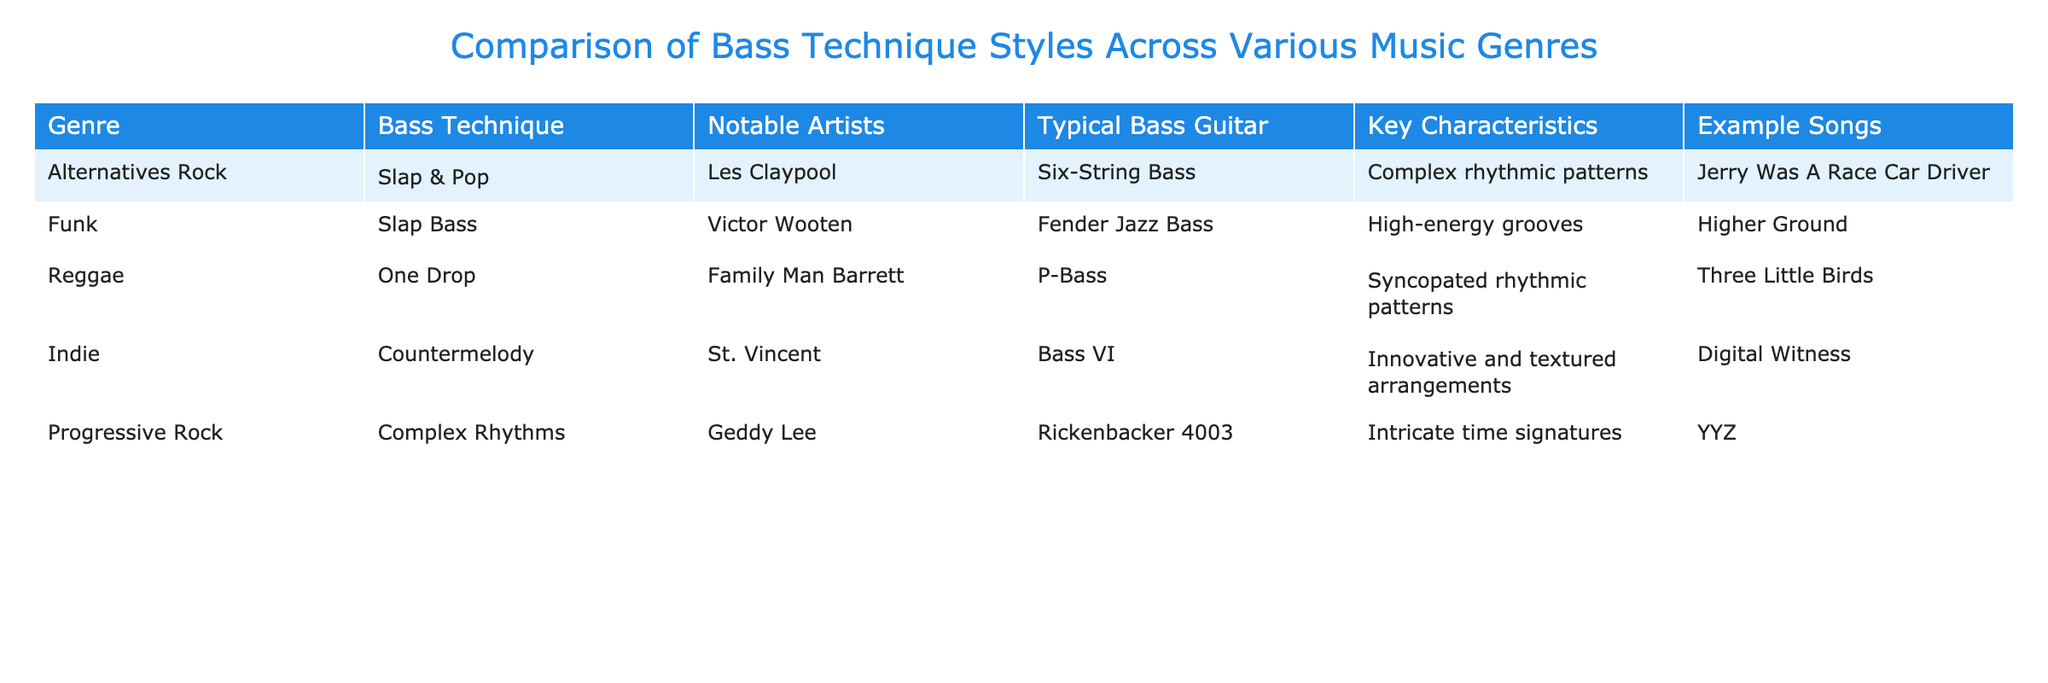What bass technique is associated with Alternatives Rock? The table indicates that the bass technique for Alternatives Rock is "Slap & Pop."
Answer: Slap & Pop Who is the notable artist linked to the slap bass technique? According to the table, Victor Wooten is the notable artist associated with the slap bass technique.
Answer: Victor Wooten What is the typical bass guitar used in Reggae? The table shows that the typical bass guitar for Reggae is "P-Bass."
Answer: P-Bass Which genre features intricate time signatures as a key characteristic? The table highlights that Progressive Rock features intricate time signatures as a key characteristic.
Answer: Progressive Rock Are there any genres that use the same bass guitar? Yes, both Funk and Reggae use the Fender Jazz Bass as their typical bass guitar.
Answer: Yes What is the notable artist for Indie music known for innovative arrangements? The table specifies that St. Vincent is the notable artist for Indie music, recognized for innovative and textured arrangements.
Answer: St. Vincent How many genres use a slap bass technique? From the table, Funk and Alternatives Rock both utilize a slap bass technique, making it two genres.
Answer: 2 Which genre has "Three Little Birds" as an example song? The table indicates that "Three Little Birds" is an example song for the Reggae genre.
Answer: Reggae List the two genres that feature complex rhythmic patterns. The table shows that Alternatives Rock and Funk both feature complex rhythmic patterns in their key characteristics.
Answer: Alternatives Rock and Funk What is the relationship between the bass technique and its notable artist in Alternates Rock? The table illustrates that in Alternatives Rock, "Slap & Pop" is the bass technique, and "Les Claypool" is the associated notable artist. Les Claypool is known for using this technique.
Answer: Les Claypool How many notable artists are listed for techniques that involve complexity? There are three notable artists listed: Les Claypool for Slap & Pop in Alternatives Rock, Victor Wooten for Slap Bass in Funk, and Geddy Lee for Complex Rhythms in Progressive Rock, indicating a total of three artists.
Answer: 3 What are the typical bass guitars for the genres mentioned? The table specifies that the typical bass guitars correspond as follows: Alternatives Rock uses Six-String Bass, Funk uses Fender Jazz Bass, Reggae uses P-Bass, Indie uses Bass VI, and Progressive Rock uses Rickenbacker 4003.
Answer: Six-String Bass, Fender Jazz Bass, P-Bass, Bass VI, Rickenbacker 4003 Does any genre mention "Higher Ground" as an example song? Yes, the Funk genre mentions "Higher Ground" as an example song.
Answer: Yes 